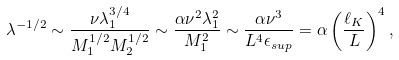Convert formula to latex. <formula><loc_0><loc_0><loc_500><loc_500>\lambda ^ { - 1 / 2 } \sim \frac { \nu \lambda _ { 1 } ^ { 3 / 4 } } { M _ { 1 } ^ { 1 / 2 } M _ { 2 } ^ { 1 / 2 } } \sim \frac { \alpha \nu ^ { 2 } \lambda _ { 1 } ^ { 2 } } { M _ { 1 } ^ { 2 } } \sim \frac { \alpha \nu ^ { 3 } } { L ^ { 4 } \epsilon _ { s u p } } = \alpha \left ( \frac { \ell _ { K } } { L } \right ) ^ { 4 } ,</formula> 